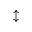<formula> <loc_0><loc_0><loc_500><loc_500>\updownarrow</formula> 